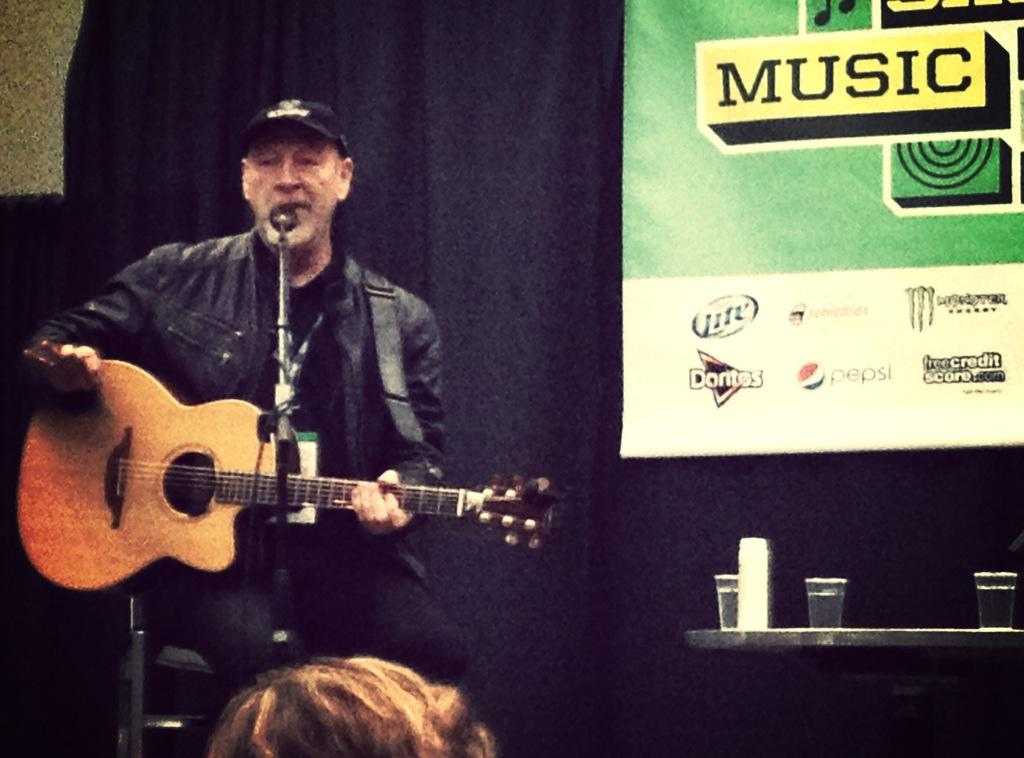Who is the main subject in the image? There is a man in the image. What is the man holding in the image? The man is holding a guitar. What is the man doing with the guitar? The man is playing the guitar. Where is the man positioned in relation to the microphone? The man is in front of a microphone. What else can be seen in the image besides the man and the microphone? There is a table in the image, and there are glasses on the table. What type of flower is growing in the prison cell in the image? There is no flower or prison cell present in the image; it features a man playing a guitar in front of a microphone. 